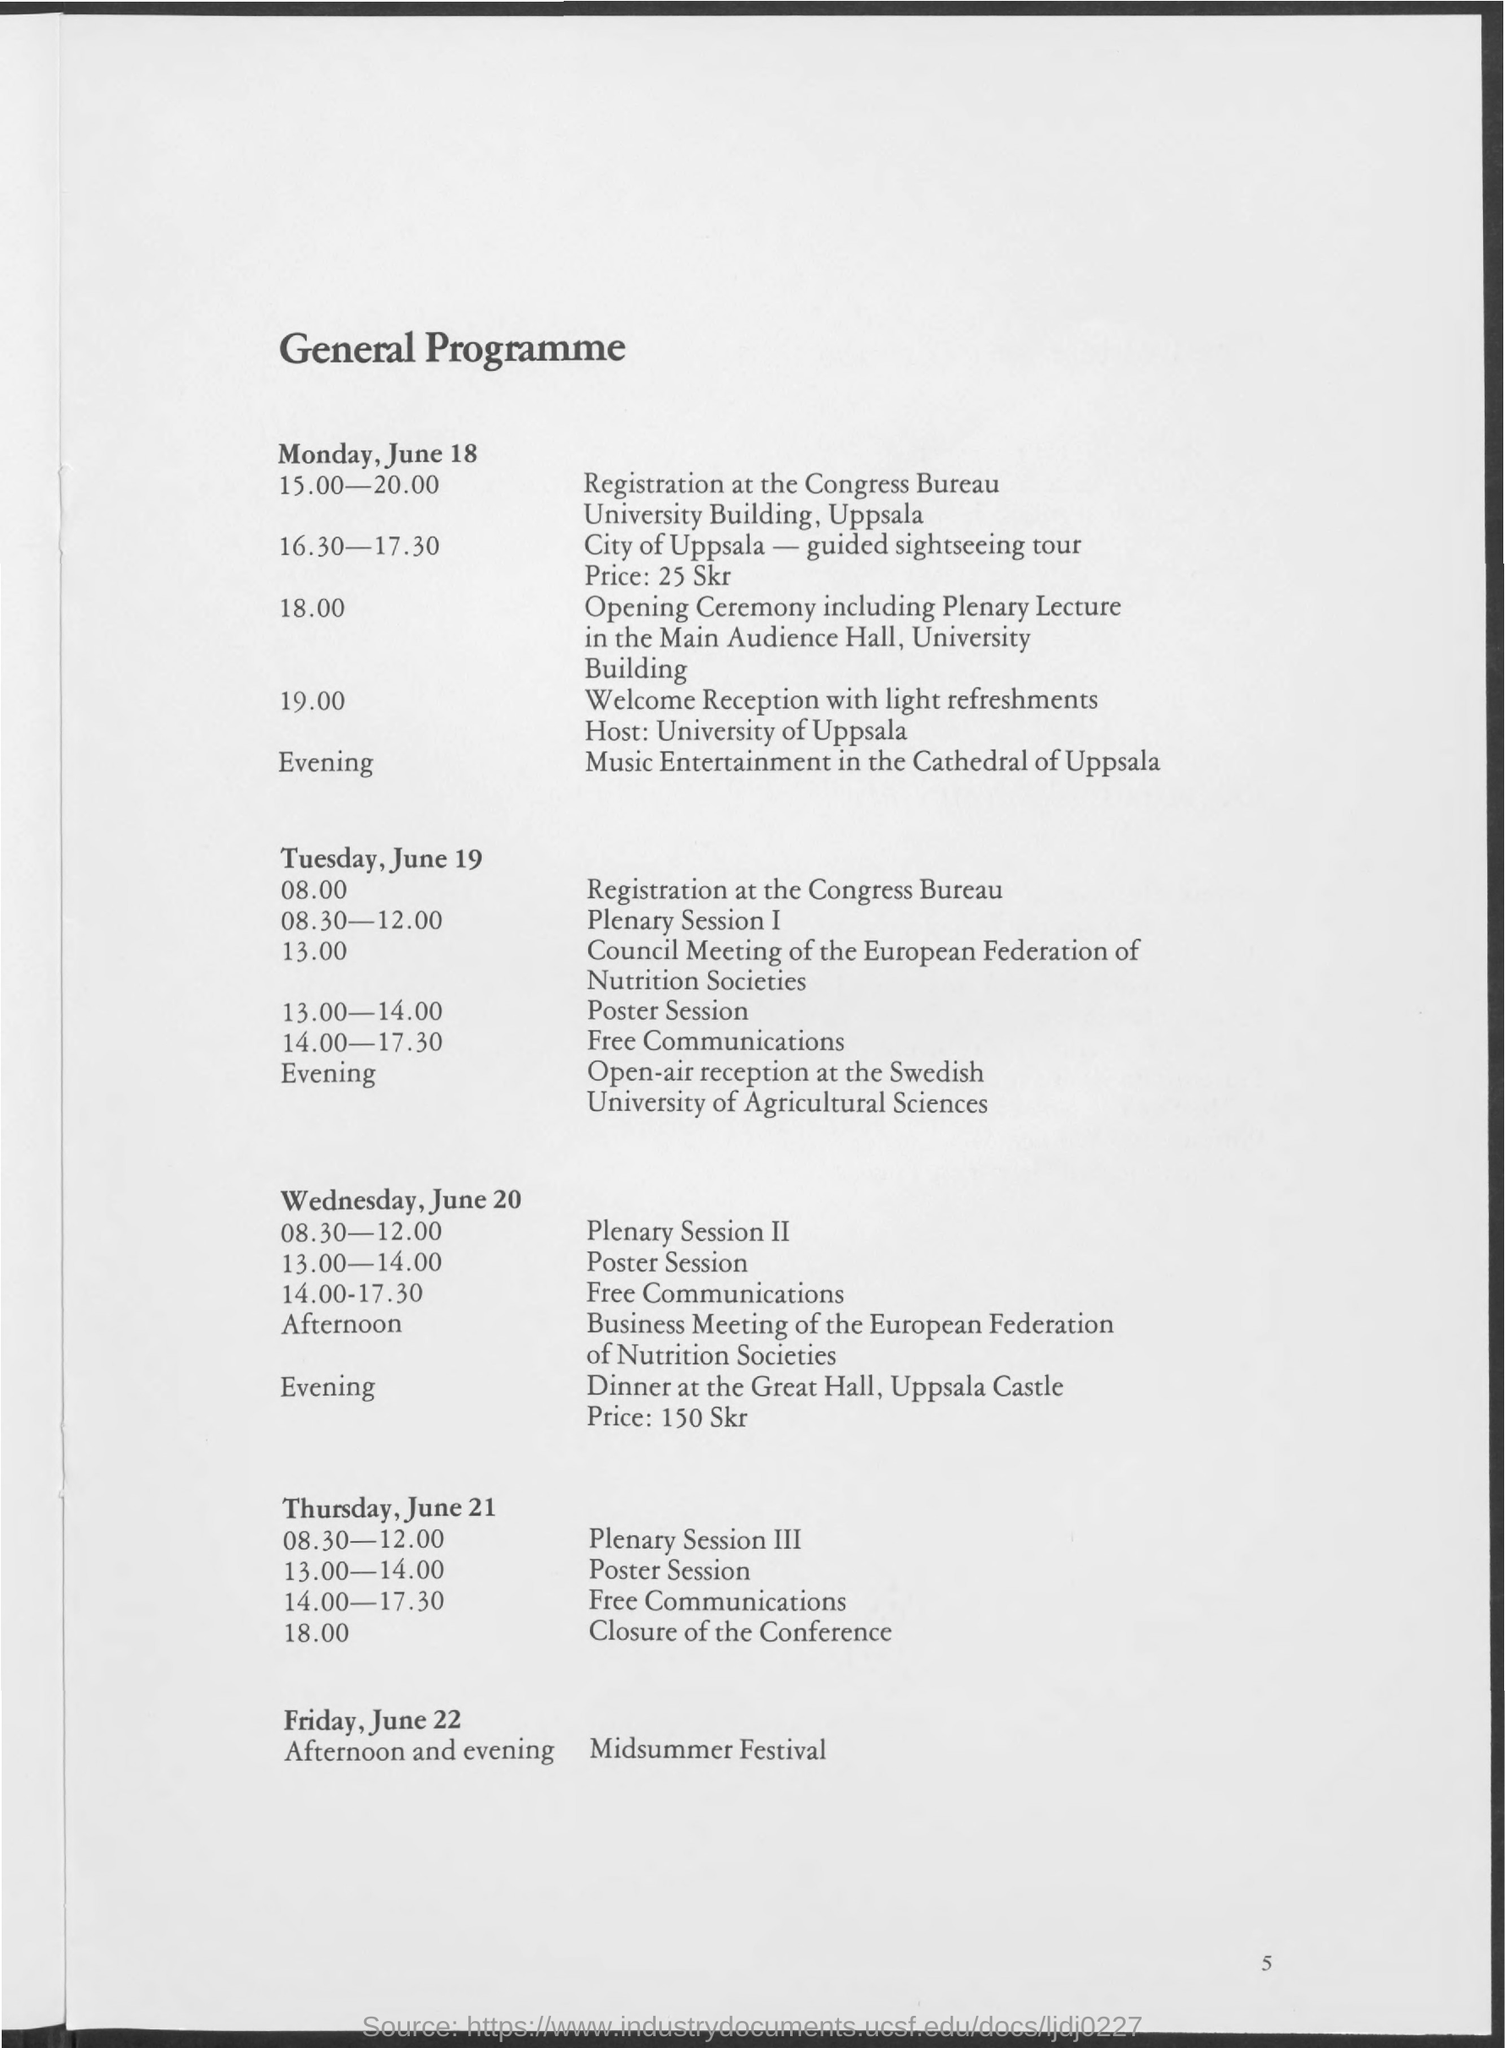What is the heading of the page?
Make the answer very short. General programme. 